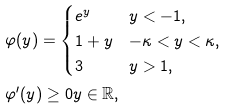Convert formula to latex. <formula><loc_0><loc_0><loc_500><loc_500>& \varphi ( y ) = \begin{cases} e ^ { y } & y < - 1 , \\ 1 + y & - \kappa < y < \kappa , \\ 3 & y > 1 , \end{cases} \\ & \varphi ^ { \prime } ( y ) \geq 0 y \in \mathbb { R } ,</formula> 